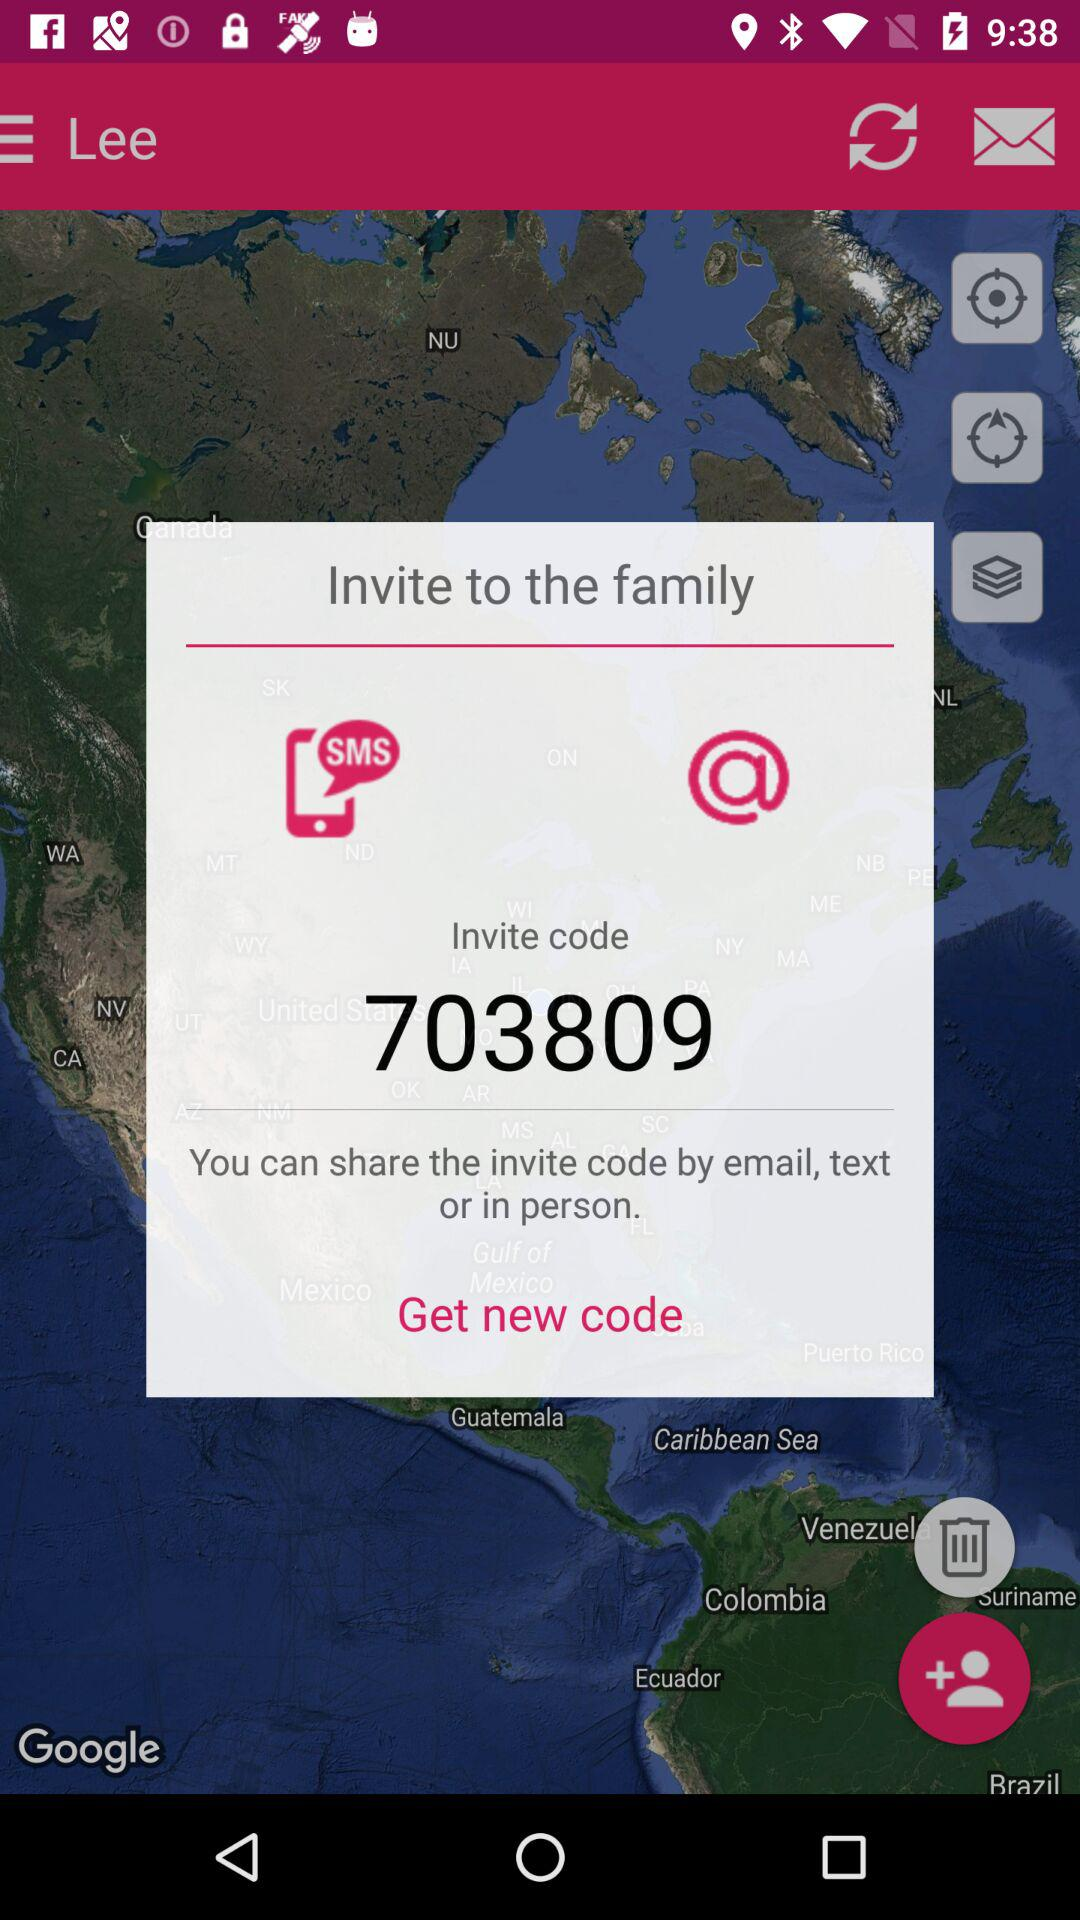What is the invite code? The invite code is "703809". 